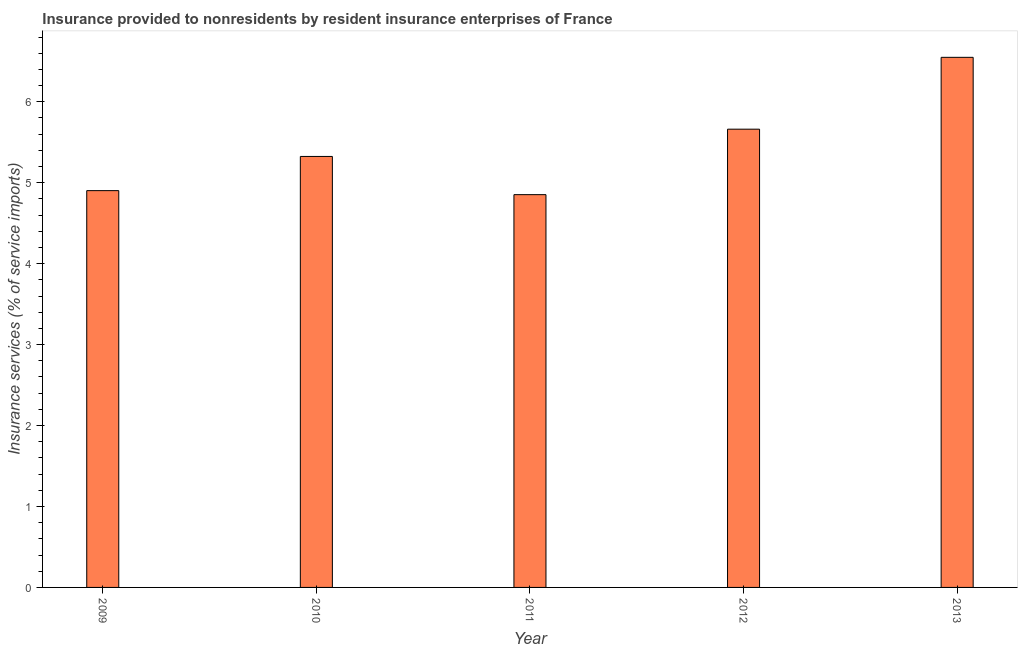Does the graph contain any zero values?
Your response must be concise. No. What is the title of the graph?
Offer a very short reply. Insurance provided to nonresidents by resident insurance enterprises of France. What is the label or title of the Y-axis?
Offer a terse response. Insurance services (% of service imports). What is the insurance and financial services in 2013?
Provide a short and direct response. 6.55. Across all years, what is the maximum insurance and financial services?
Provide a short and direct response. 6.55. Across all years, what is the minimum insurance and financial services?
Your answer should be compact. 4.85. What is the sum of the insurance and financial services?
Make the answer very short. 27.29. What is the difference between the insurance and financial services in 2009 and 2012?
Your response must be concise. -0.76. What is the average insurance and financial services per year?
Make the answer very short. 5.46. What is the median insurance and financial services?
Keep it short and to the point. 5.32. Do a majority of the years between 2009 and 2010 (inclusive) have insurance and financial services greater than 0.4 %?
Offer a very short reply. Yes. What is the ratio of the insurance and financial services in 2012 to that in 2013?
Your answer should be very brief. 0.86. Is the insurance and financial services in 2010 less than that in 2011?
Provide a short and direct response. No. What is the difference between the highest and the second highest insurance and financial services?
Your response must be concise. 0.89. What is the difference between the highest and the lowest insurance and financial services?
Ensure brevity in your answer.  1.7. How many bars are there?
Offer a terse response. 5. What is the difference between two consecutive major ticks on the Y-axis?
Your answer should be very brief. 1. Are the values on the major ticks of Y-axis written in scientific E-notation?
Your response must be concise. No. What is the Insurance services (% of service imports) of 2009?
Offer a terse response. 4.9. What is the Insurance services (% of service imports) of 2010?
Your answer should be very brief. 5.32. What is the Insurance services (% of service imports) of 2011?
Provide a succinct answer. 4.85. What is the Insurance services (% of service imports) of 2012?
Provide a succinct answer. 5.66. What is the Insurance services (% of service imports) in 2013?
Ensure brevity in your answer.  6.55. What is the difference between the Insurance services (% of service imports) in 2009 and 2010?
Your answer should be very brief. -0.42. What is the difference between the Insurance services (% of service imports) in 2009 and 2011?
Provide a succinct answer. 0.05. What is the difference between the Insurance services (% of service imports) in 2009 and 2012?
Make the answer very short. -0.76. What is the difference between the Insurance services (% of service imports) in 2009 and 2013?
Provide a succinct answer. -1.65. What is the difference between the Insurance services (% of service imports) in 2010 and 2011?
Keep it short and to the point. 0.47. What is the difference between the Insurance services (% of service imports) in 2010 and 2012?
Make the answer very short. -0.34. What is the difference between the Insurance services (% of service imports) in 2010 and 2013?
Your answer should be very brief. -1.22. What is the difference between the Insurance services (% of service imports) in 2011 and 2012?
Provide a succinct answer. -0.81. What is the difference between the Insurance services (% of service imports) in 2011 and 2013?
Keep it short and to the point. -1.7. What is the difference between the Insurance services (% of service imports) in 2012 and 2013?
Offer a very short reply. -0.89. What is the ratio of the Insurance services (% of service imports) in 2009 to that in 2010?
Offer a terse response. 0.92. What is the ratio of the Insurance services (% of service imports) in 2009 to that in 2012?
Ensure brevity in your answer.  0.87. What is the ratio of the Insurance services (% of service imports) in 2009 to that in 2013?
Provide a succinct answer. 0.75. What is the ratio of the Insurance services (% of service imports) in 2010 to that in 2011?
Make the answer very short. 1.1. What is the ratio of the Insurance services (% of service imports) in 2010 to that in 2012?
Your response must be concise. 0.94. What is the ratio of the Insurance services (% of service imports) in 2010 to that in 2013?
Your answer should be compact. 0.81. What is the ratio of the Insurance services (% of service imports) in 2011 to that in 2012?
Provide a succinct answer. 0.86. What is the ratio of the Insurance services (% of service imports) in 2011 to that in 2013?
Your answer should be very brief. 0.74. What is the ratio of the Insurance services (% of service imports) in 2012 to that in 2013?
Provide a short and direct response. 0.86. 